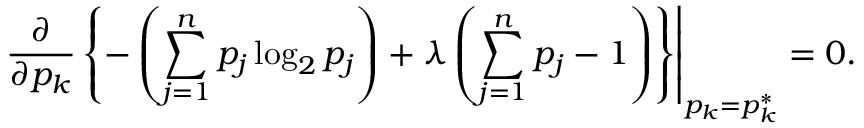<formula> <loc_0><loc_0><loc_500><loc_500>{ \frac { \partial } { \partial p _ { k } } } \left \{ - \left ( \sum _ { j = 1 } ^ { n } p _ { j } \log _ { 2 } p _ { j } \right ) + \lambda \left ( \sum _ { j = 1 } ^ { n } p _ { j } - 1 \right ) \right \} \right | _ { p _ { k } = p _ { k } ^ { * } } = 0 .</formula> 